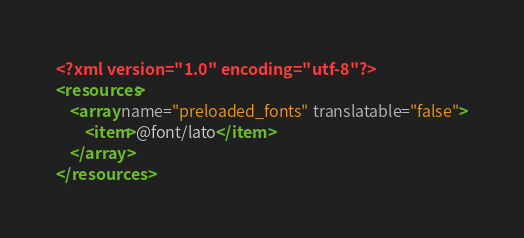Convert code to text. <code><loc_0><loc_0><loc_500><loc_500><_XML_><?xml version="1.0" encoding="utf-8"?>
<resources>
    <array name="preloaded_fonts" translatable="false">
        <item>@font/lato</item>
    </array>
</resources>
</code> 